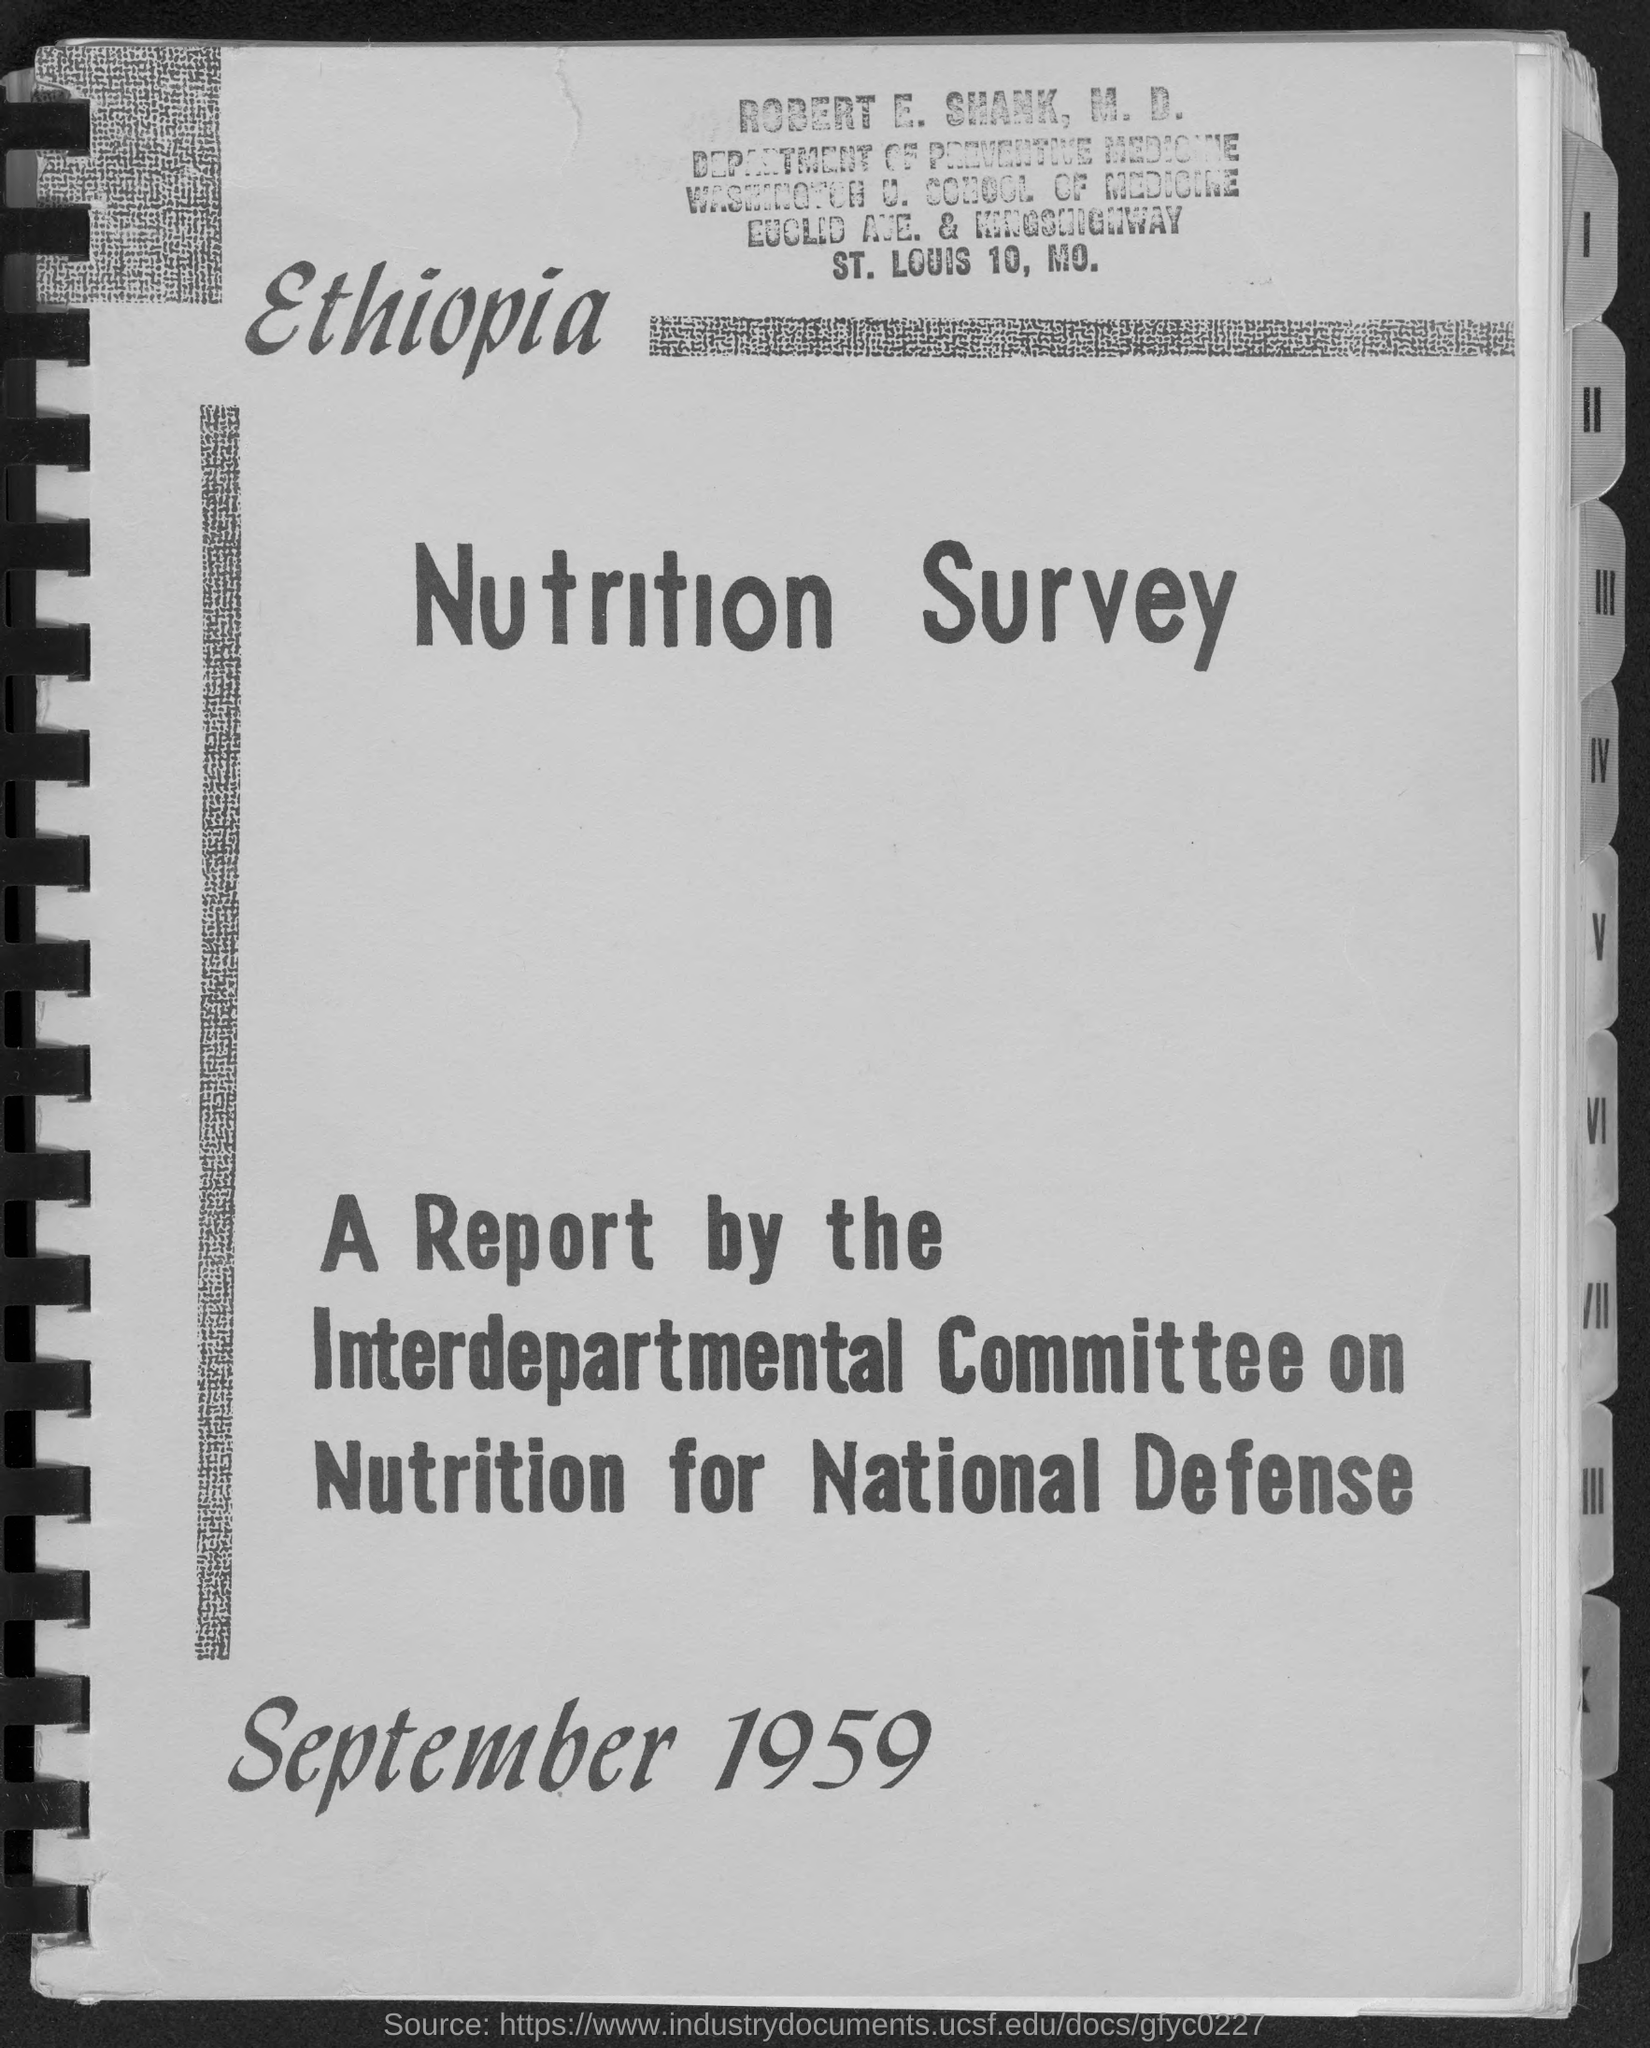Highlight a few significant elements in this photo. Robert E. Shank, M.D., is a member of the Department of Preventive Medicine. The month and year at the bottom of the page are September 1959. 